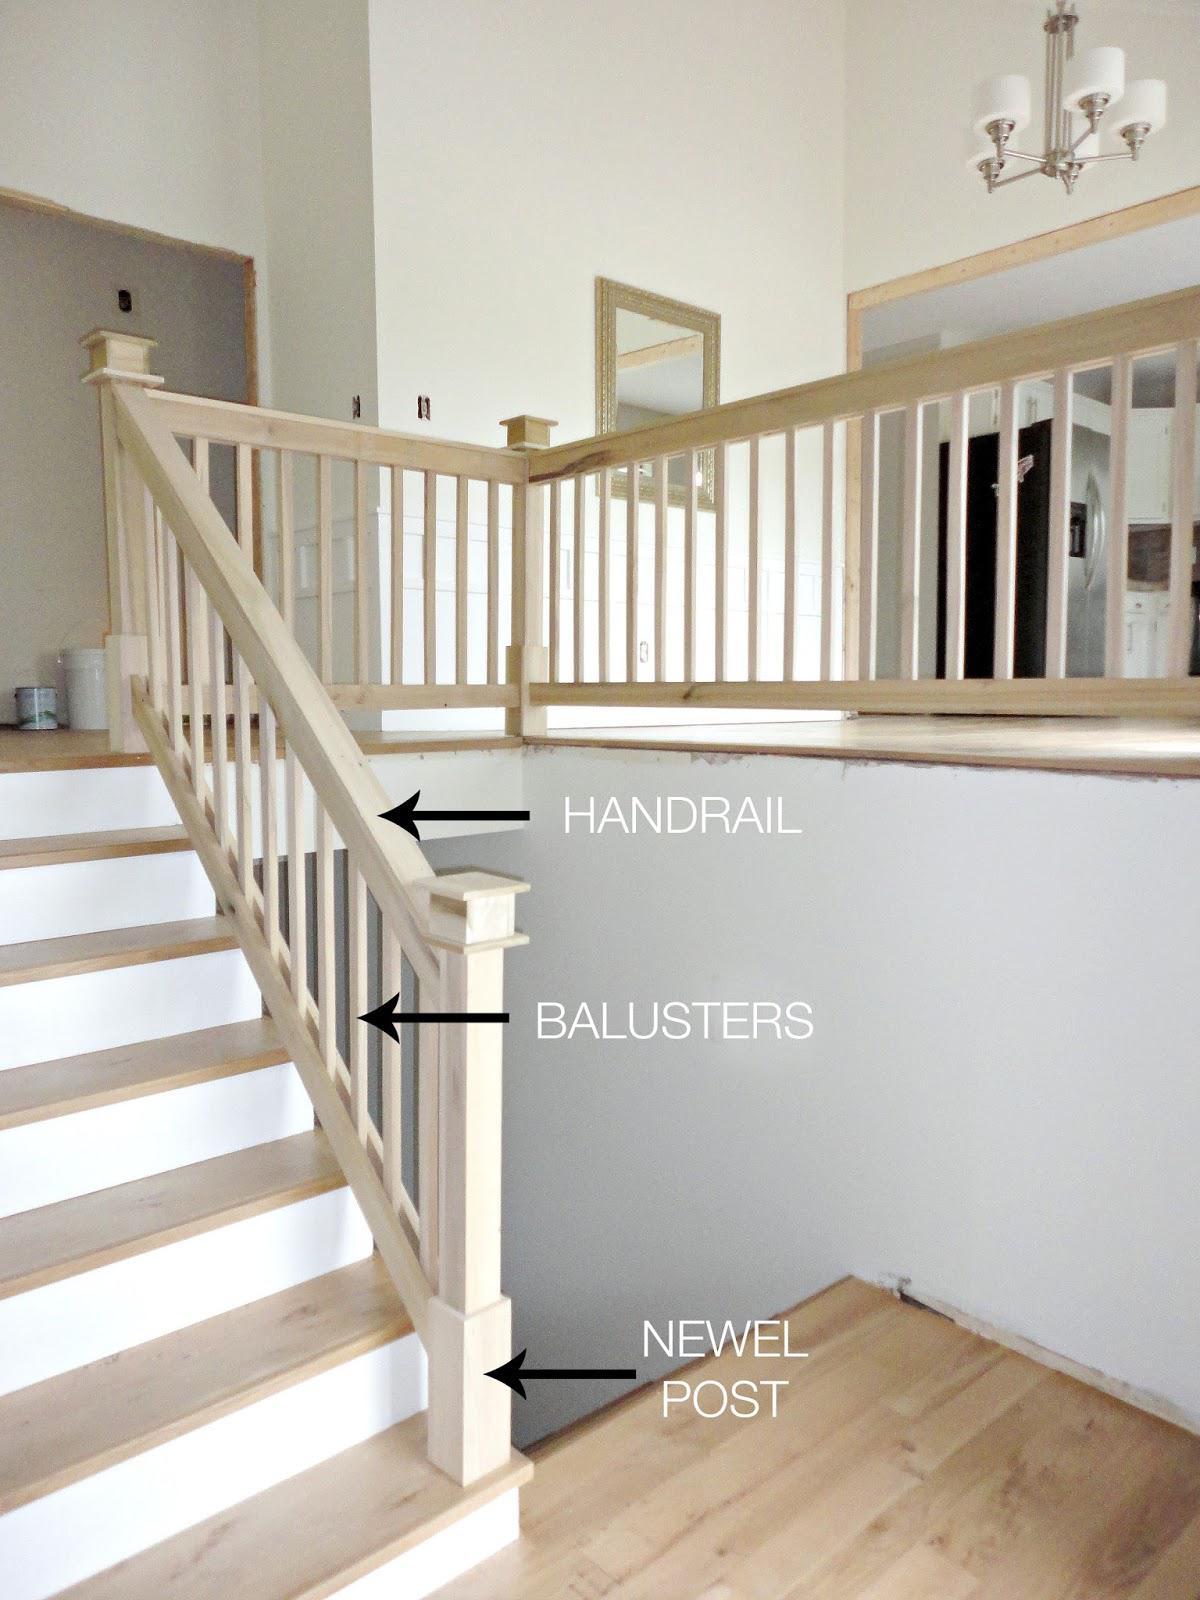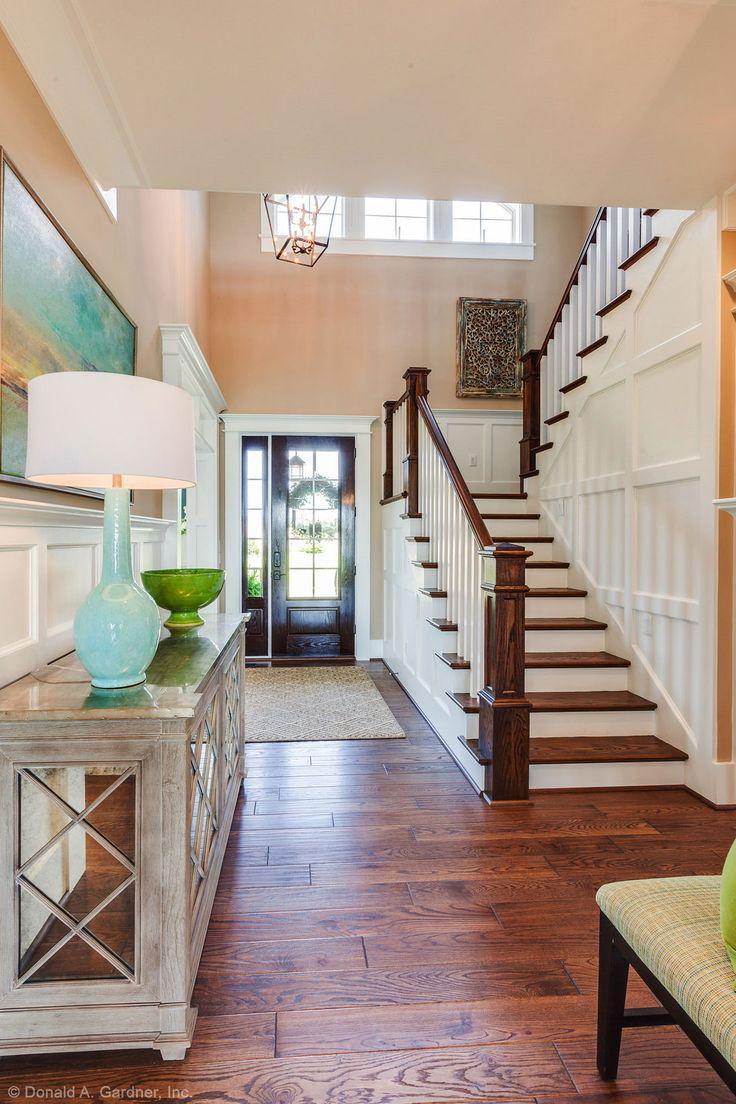The first image is the image on the left, the second image is the image on the right. Considering the images on both sides, is "The left image features a curving staircase with a wooden handrail and vertical wrought iron bars with a dimensional decorative element." valid? Answer yes or no. No. The first image is the image on the left, the second image is the image on the right. Examine the images to the left and right. Is the description "In at least one image there are brown railed stair that curve as they come down to the floor." accurate? Answer yes or no. No. 